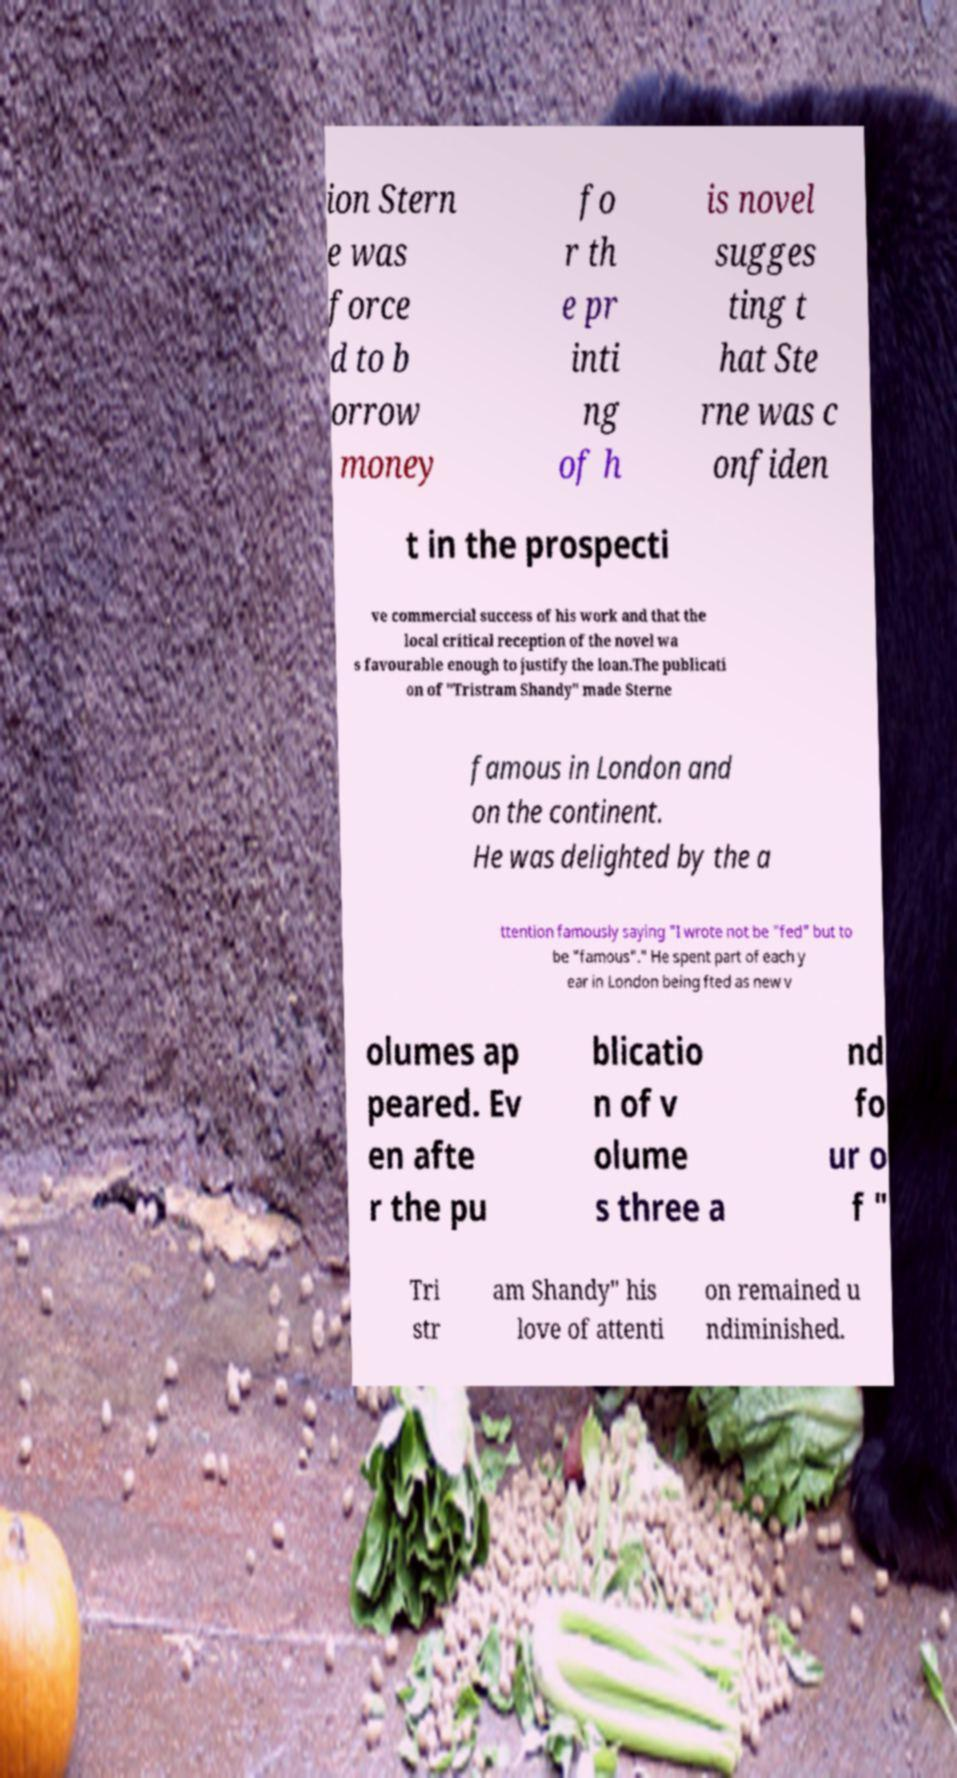For documentation purposes, I need the text within this image transcribed. Could you provide that? ion Stern e was force d to b orrow money fo r th e pr inti ng of h is novel sugges ting t hat Ste rne was c onfiden t in the prospecti ve commercial success of his work and that the local critical reception of the novel wa s favourable enough to justify the loan.The publicati on of "Tristram Shandy" made Sterne famous in London and on the continent. He was delighted by the a ttention famously saying "I wrote not be "fed" but to be "famous"." He spent part of each y ear in London being fted as new v olumes ap peared. Ev en afte r the pu blicatio n of v olume s three a nd fo ur o f " Tri str am Shandy" his love of attenti on remained u ndiminished. 